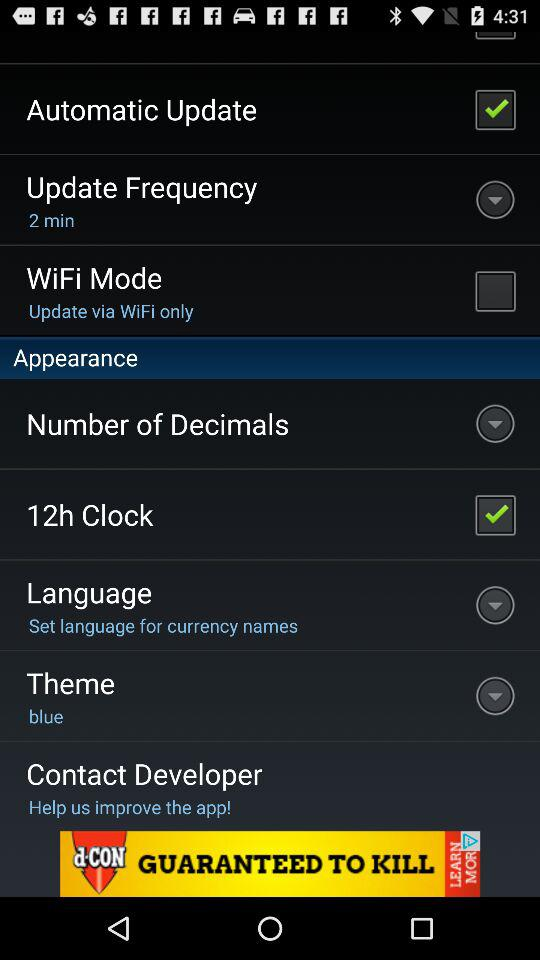What is the current status of "WiFi Mode"? The current status of "WiFi Mode" is "off". 